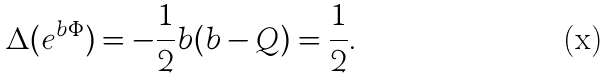<formula> <loc_0><loc_0><loc_500><loc_500>\Delta ( e ^ { b \Phi } ) = - \frac { 1 } { 2 } b ( b - Q ) = \frac { 1 } { 2 } .</formula> 